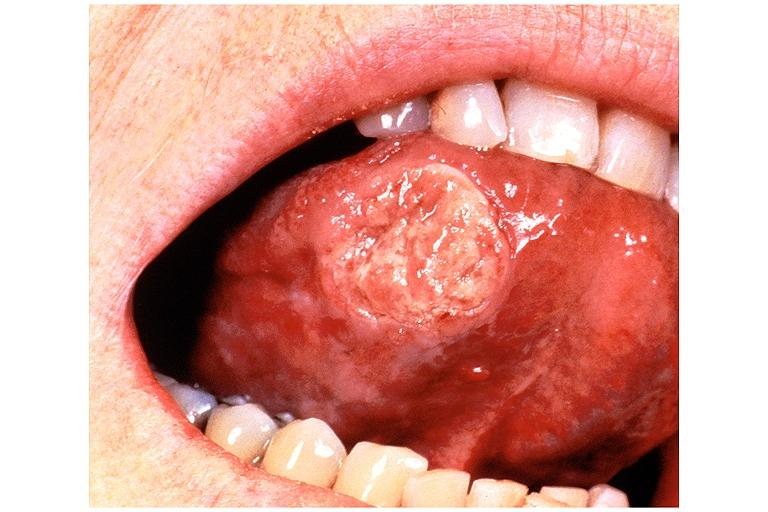what does this image show?
Answer the question using a single word or phrase. Squamous cell carcinoma 